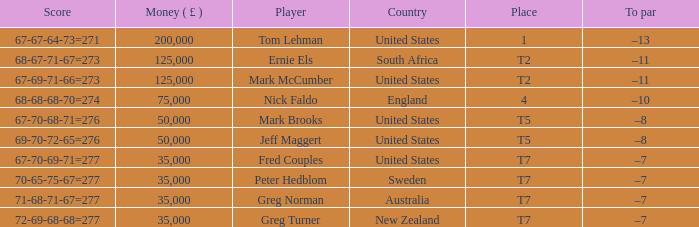What does "to par" represent in the context of the united states, with a monetary value of over 125,000 pounds and a score of "67-70-68-71=276"? None. 